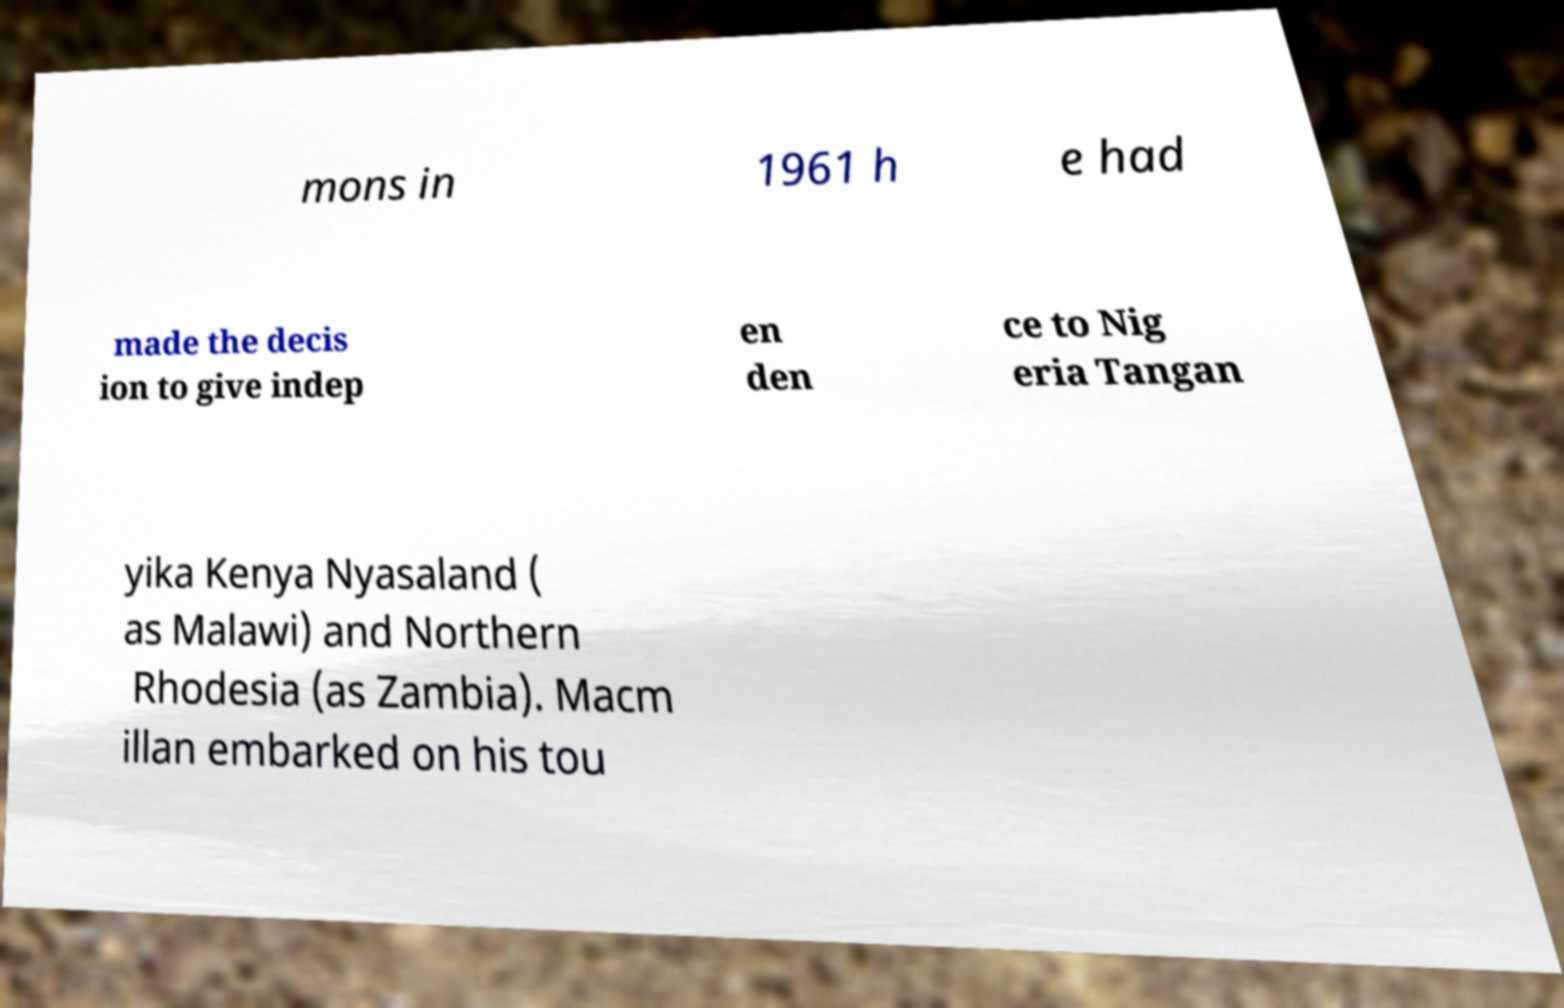Can you read and provide the text displayed in the image?This photo seems to have some interesting text. Can you extract and type it out for me? mons in 1961 h e had made the decis ion to give indep en den ce to Nig eria Tangan yika Kenya Nyasaland ( as Malawi) and Northern Rhodesia (as Zambia). Macm illan embarked on his tou 